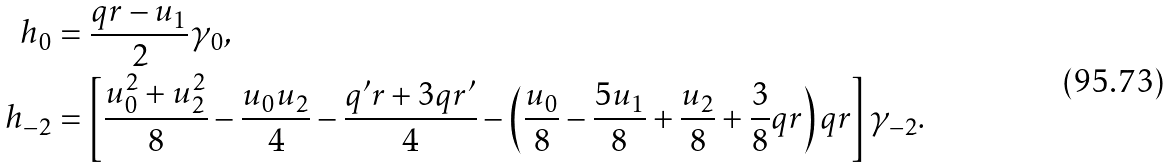<formula> <loc_0><loc_0><loc_500><loc_500>h _ { 0 } & = \frac { q r - u _ { 1 } } { 2 } \gamma _ { 0 } , \\ h _ { - 2 } & = \left [ \frac { u _ { 0 } ^ { 2 } + u _ { 2 } ^ { 2 } } { 8 } - \frac { u _ { 0 } u _ { 2 } } { 4 } - \frac { q ^ { \prime } r + 3 q r ^ { \prime } } { 4 } - \left ( \frac { u _ { 0 } } { 8 } - \frac { 5 u _ { 1 } } { 8 } + \frac { u _ { 2 } } { 8 } + \frac { 3 } { 8 } q r \right ) q r \right ] \gamma _ { - 2 } .</formula> 